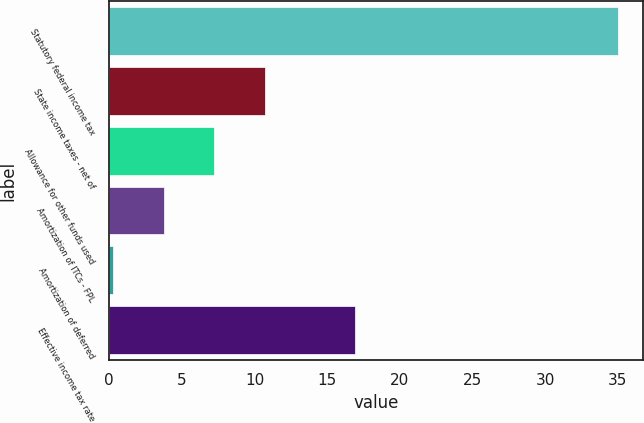Convert chart. <chart><loc_0><loc_0><loc_500><loc_500><bar_chart><fcel>Statutory federal income tax<fcel>State income taxes - net of<fcel>Allowance for other funds used<fcel>Amortization of ITCs - FPL<fcel>Amortization of deferred<fcel>Effective income tax rate<nl><fcel>35<fcel>10.71<fcel>7.24<fcel>3.77<fcel>0.3<fcel>16.9<nl></chart> 